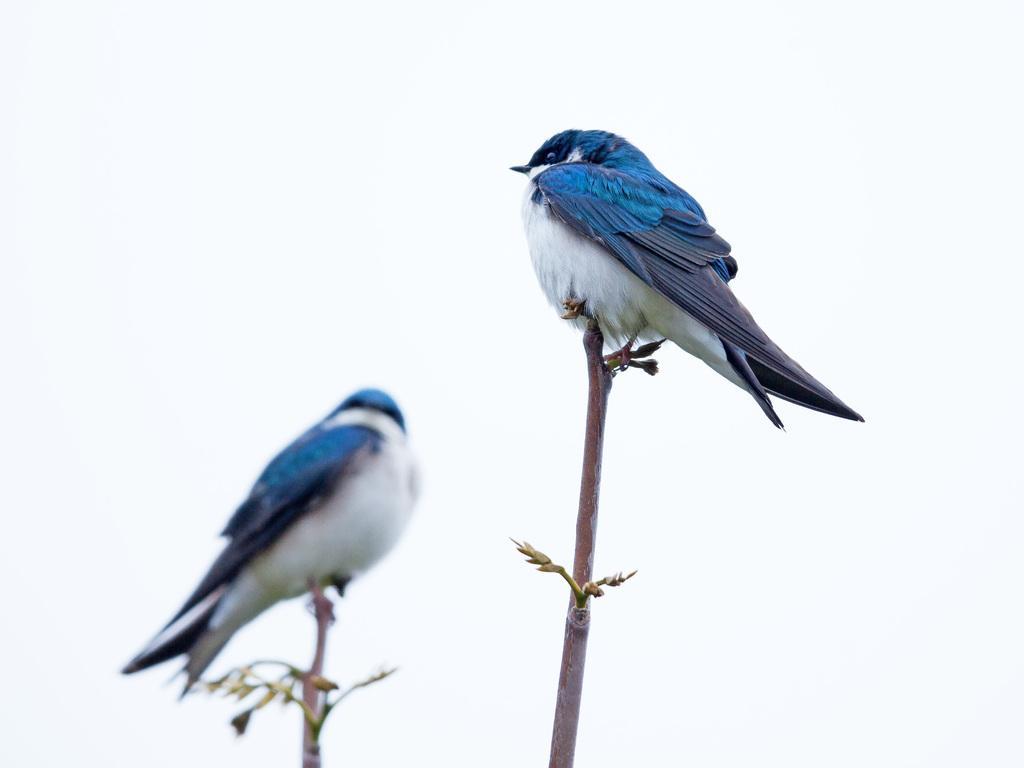In one or two sentences, can you explain what this image depicts? In this picture I can see couple of birds on the branches, they are white blue and black in color and I can see white color background. 